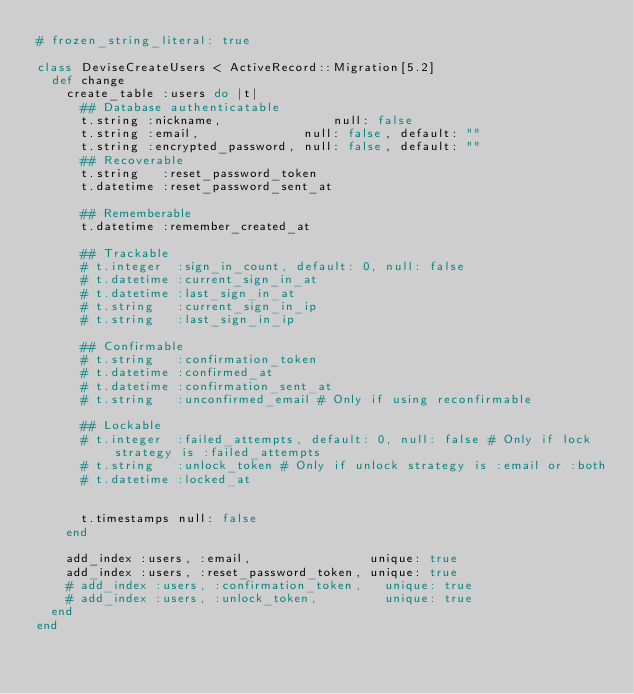<code> <loc_0><loc_0><loc_500><loc_500><_Ruby_># frozen_string_literal: true

class DeviseCreateUsers < ActiveRecord::Migration[5.2]
  def change
    create_table :users do |t|
      ## Database authenticatable
      t.string :nickname,               null: false
      t.string :email,              null: false, default: ""
      t.string :encrypted_password, null: false, default: ""
      ## Recoverable
      t.string   :reset_password_token
      t.datetime :reset_password_sent_at

      ## Rememberable
      t.datetime :remember_created_at

      ## Trackable
      # t.integer  :sign_in_count, default: 0, null: false
      # t.datetime :current_sign_in_at
      # t.datetime :last_sign_in_at
      # t.string   :current_sign_in_ip
      # t.string   :last_sign_in_ip

      ## Confirmable
      # t.string   :confirmation_token
      # t.datetime :confirmed_at
      # t.datetime :confirmation_sent_at
      # t.string   :unconfirmed_email # Only if using reconfirmable

      ## Lockable
      # t.integer  :failed_attempts, default: 0, null: false # Only if lock strategy is :failed_attempts
      # t.string   :unlock_token # Only if unlock strategy is :email or :both
      # t.datetime :locked_at


      t.timestamps null: false
    end

    add_index :users, :email,                unique: true
    add_index :users, :reset_password_token, unique: true
    # add_index :users, :confirmation_token,   unique: true
    # add_index :users, :unlock_token,         unique: true
  end
end
</code> 